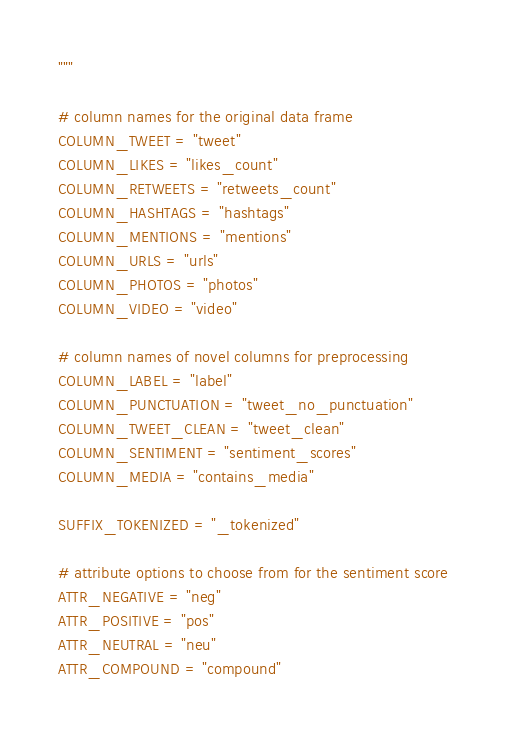<code> <loc_0><loc_0><loc_500><loc_500><_Python_>"""

# column names for the original data frame
COLUMN_TWEET = "tweet"
COLUMN_LIKES = "likes_count"
COLUMN_RETWEETS = "retweets_count"
COLUMN_HASHTAGS = "hashtags"
COLUMN_MENTIONS = "mentions"
COLUMN_URLS = "urls"
COLUMN_PHOTOS = "photos"
COLUMN_VIDEO = "video"

# column names of novel columns for preprocessing
COLUMN_LABEL = "label"
COLUMN_PUNCTUATION = "tweet_no_punctuation"
COLUMN_TWEET_CLEAN = "tweet_clean"
COLUMN_SENTIMENT = "sentiment_scores"
COLUMN_MEDIA = "contains_media"

SUFFIX_TOKENIZED = "_tokenized"

# attribute options to choose from for the sentiment score
ATTR_NEGATIVE = "neg"
ATTR_POSITIVE = "pos"
ATTR_NEUTRAL = "neu"
ATTR_COMPOUND = "compound"
</code> 